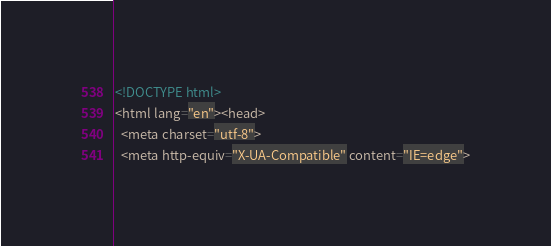<code> <loc_0><loc_0><loc_500><loc_500><_HTML_><!DOCTYPE html>
<html lang="en"><head>
  <meta charset="utf-8">
  <meta http-equiv="X-UA-Compatible" content="IE=edge"></code> 